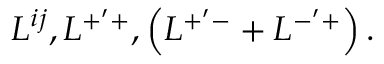Convert formula to latex. <formula><loc_0><loc_0><loc_500><loc_500>L ^ { i j } , L ^ { + ^ { \prime } + } , \left ( L ^ { + ^ { \prime } - } + L ^ { - ^ { \prime } + } \right ) .</formula> 